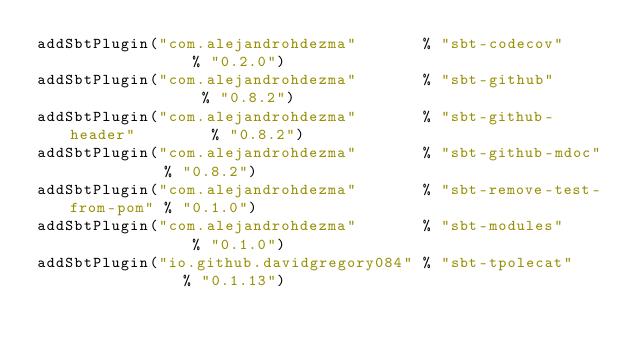<code> <loc_0><loc_0><loc_500><loc_500><_Scala_>addSbtPlugin("com.alejandrohdezma"       % "sbt-codecov"              % "0.2.0")
addSbtPlugin("com.alejandrohdezma"       % "sbt-github"               % "0.8.2")
addSbtPlugin("com.alejandrohdezma"       % "sbt-github-header"        % "0.8.2")
addSbtPlugin("com.alejandrohdezma"       % "sbt-github-mdoc"          % "0.8.2")
addSbtPlugin("com.alejandrohdezma"       % "sbt-remove-test-from-pom" % "0.1.0")
addSbtPlugin("com.alejandrohdezma"       % "sbt-modules"              % "0.1.0")
addSbtPlugin("io.github.davidgregory084" % "sbt-tpolecat"             % "0.1.13")
</code> 